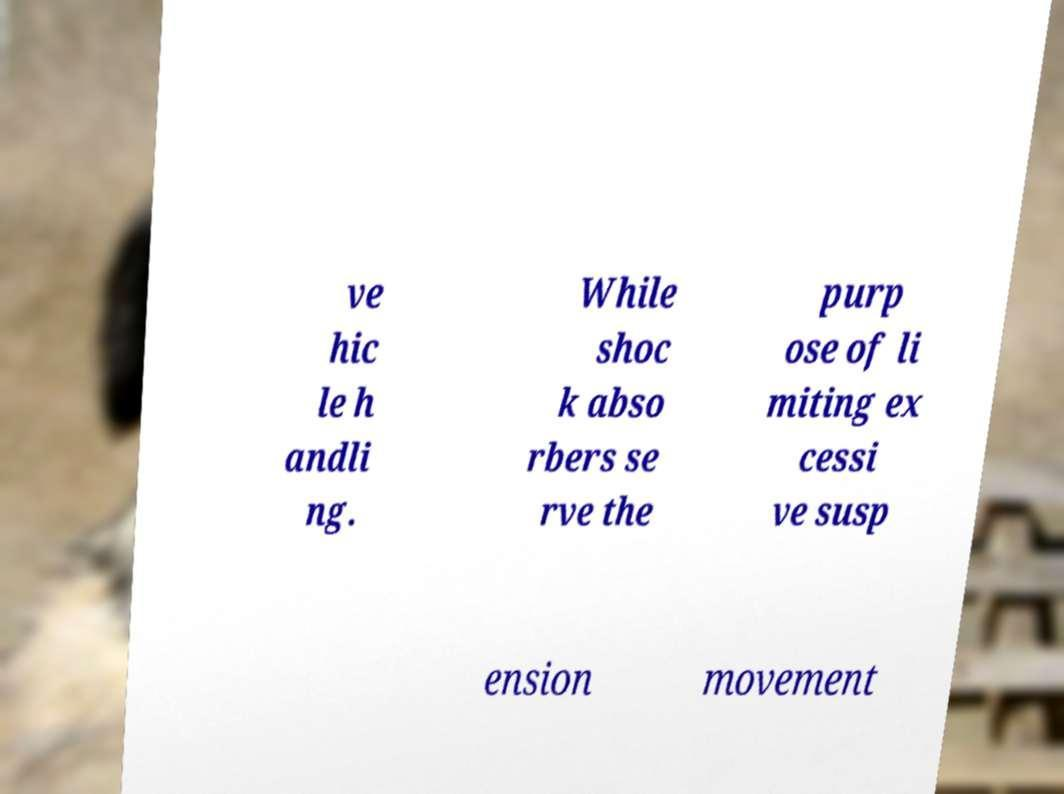Can you read and provide the text displayed in the image?This photo seems to have some interesting text. Can you extract and type it out for me? ve hic le h andli ng. While shoc k abso rbers se rve the purp ose of li miting ex cessi ve susp ension movement 